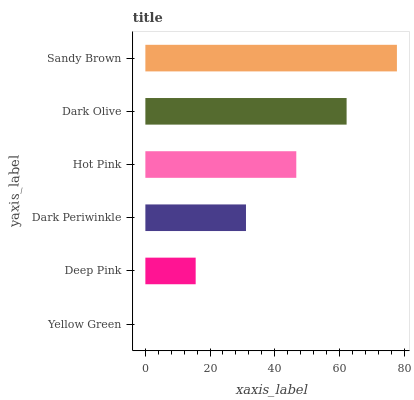Is Yellow Green the minimum?
Answer yes or no. Yes. Is Sandy Brown the maximum?
Answer yes or no. Yes. Is Deep Pink the minimum?
Answer yes or no. No. Is Deep Pink the maximum?
Answer yes or no. No. Is Deep Pink greater than Yellow Green?
Answer yes or no. Yes. Is Yellow Green less than Deep Pink?
Answer yes or no. Yes. Is Yellow Green greater than Deep Pink?
Answer yes or no. No. Is Deep Pink less than Yellow Green?
Answer yes or no. No. Is Hot Pink the high median?
Answer yes or no. Yes. Is Dark Periwinkle the low median?
Answer yes or no. Yes. Is Sandy Brown the high median?
Answer yes or no. No. Is Dark Olive the low median?
Answer yes or no. No. 